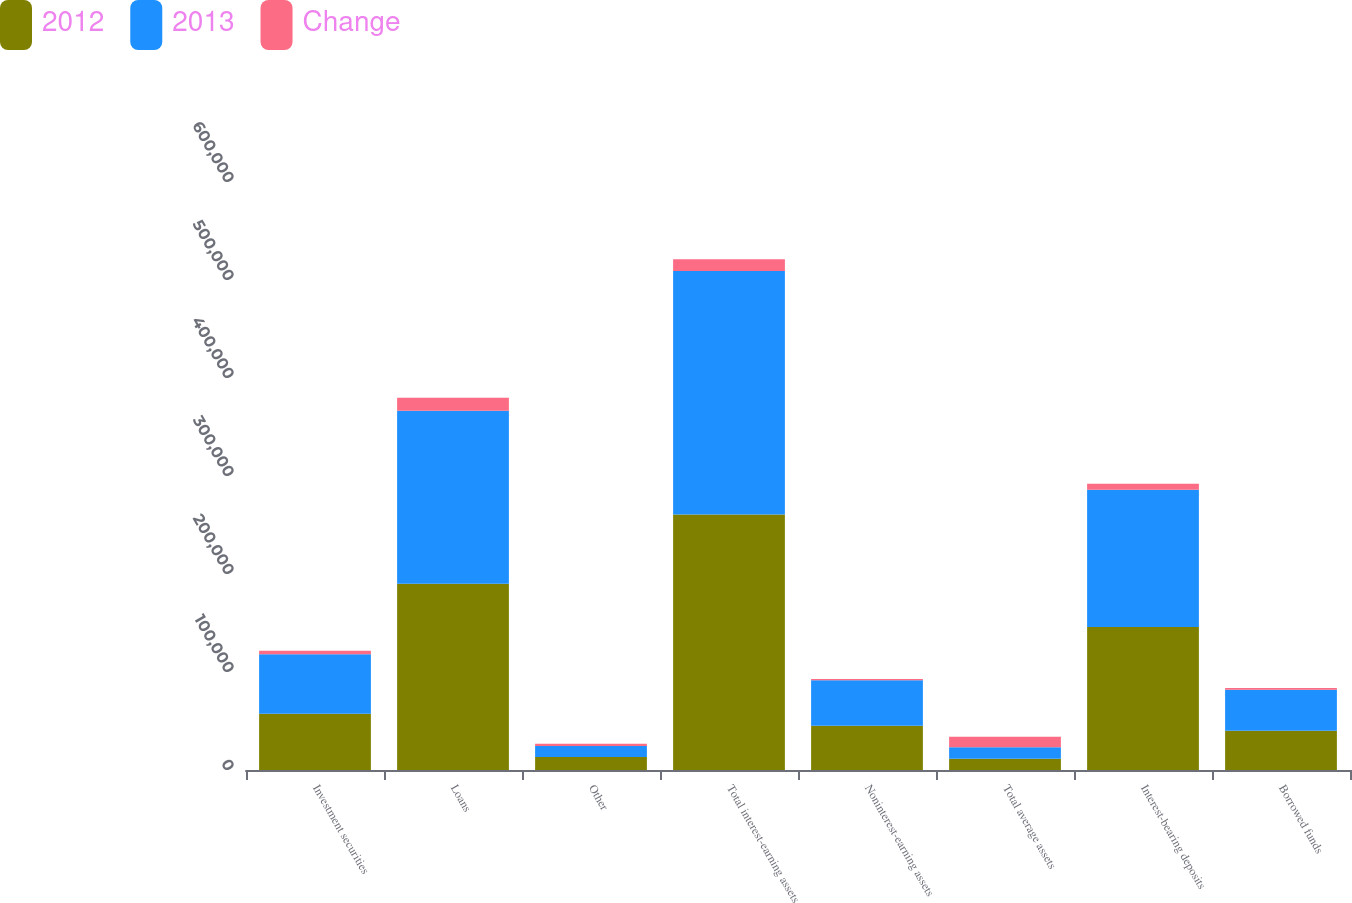Convert chart to OTSL. <chart><loc_0><loc_0><loc_500><loc_500><stacked_bar_chart><ecel><fcel>Investment securities<fcel>Loans<fcel>Other<fcel>Total interest-earning assets<fcel>Noninterest-earning assets<fcel>Total average assets<fcel>Interest-bearing deposits<fcel>Borrowed funds<nl><fcel>2012<fcel>57319<fcel>189973<fcel>13353<fcel>260645<fcel>45121<fcel>11605.5<fcel>146000<fcel>40022<nl><fcel>2013<fcel>60816<fcel>176618<fcel>11120<fcel>248554<fcel>46471<fcel>11605.5<fcel>139942<fcel>41844<nl><fcel>Change<fcel>3497<fcel>13355<fcel>2233<fcel>12091<fcel>1350<fcel>10741<fcel>6058<fcel>1822<nl><fcel>nan<fcel>6<fcel>8<fcel>20<fcel>5<fcel>3<fcel>4<fcel>4<fcel>4<nl></chart> 